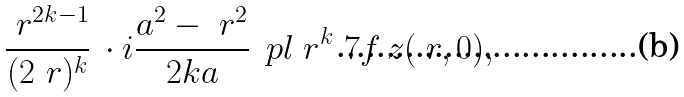Convert formula to latex. <formula><loc_0><loc_0><loc_500><loc_500>\frac { \ r ^ { 2 k - 1 } } { ( 2 \ r ) ^ { k } } \, \cdot i \frac { a ^ { 2 } - \ r ^ { 2 } } { 2 k a } \, \ p l _ { \ } r ^ { k } \ 7 f _ { \ } z ( \ r , 0 ) ,</formula> 